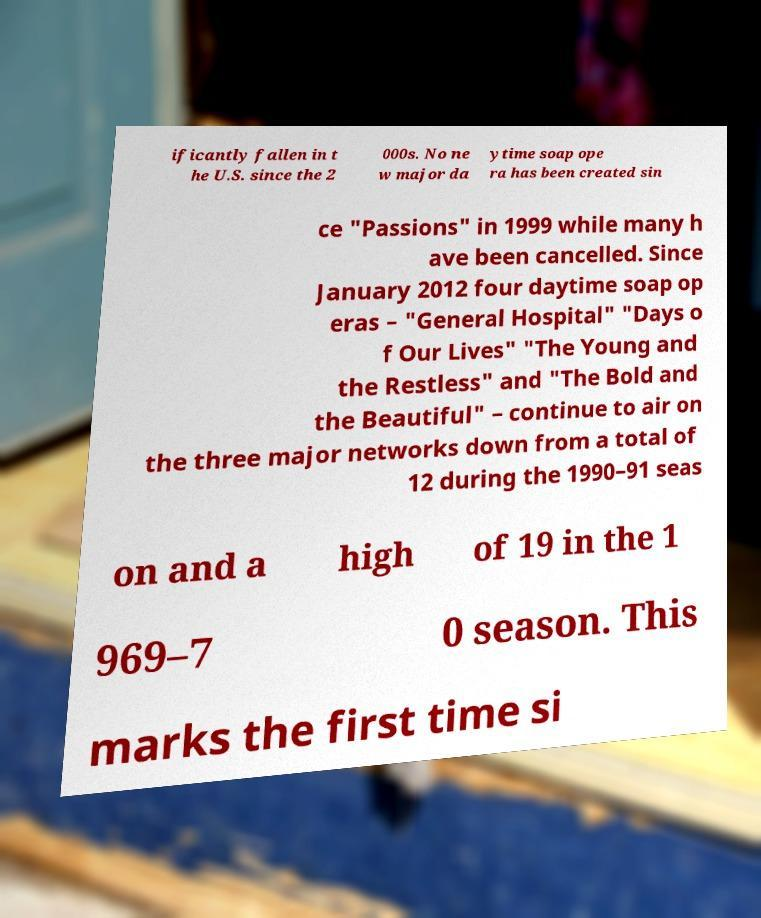I need the written content from this picture converted into text. Can you do that? ificantly fallen in t he U.S. since the 2 000s. No ne w major da ytime soap ope ra has been created sin ce "Passions" in 1999 while many h ave been cancelled. Since January 2012 four daytime soap op eras – "General Hospital" "Days o f Our Lives" "The Young and the Restless" and "The Bold and the Beautiful" – continue to air on the three major networks down from a total of 12 during the 1990–91 seas on and a high of 19 in the 1 969–7 0 season. This marks the first time si 